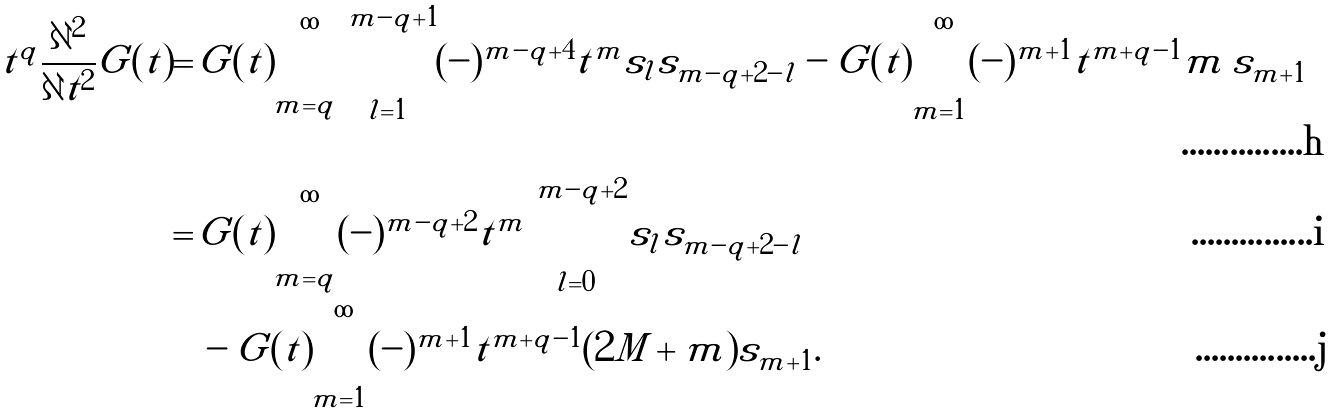<formula> <loc_0><loc_0><loc_500><loc_500>t ^ { q } \frac { \partial ^ { 2 } } { \partial t ^ { 2 } } G ( t ) = & \, G ( t ) \sum _ { m = q } ^ { \infty } \sum _ { l = 1 } ^ { m - q + 1 } ( - ) ^ { m - q + 4 } t ^ { m } s _ { l } s _ { m - q + 2 - l } - G ( t ) \sum _ { m = 1 } ^ { \infty } ( - ) ^ { m + 1 } t ^ { m + q - 1 } m \, s _ { m + 1 } \\ = & \, G ( t ) \sum _ { m = q } ^ { \infty } ( - ) ^ { m - q + 2 } t ^ { m } \sum _ { l = 0 } ^ { m - q + 2 } s _ { l } s _ { m - q + 2 - l } \\ & \, - G ( t ) \sum _ { m = 1 } ^ { \infty } ( - ) ^ { m + 1 } t ^ { m + q - 1 } ( 2 M + m ) s _ { m + 1 } .</formula> 